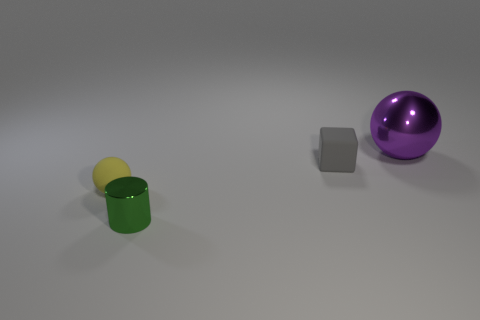There is a thing behind the gray matte cube; does it have the same shape as the tiny gray object?
Offer a very short reply. No. The shiny thing in front of the small gray rubber object has what shape?
Offer a terse response. Cylinder. What number of yellow matte balls are the same size as the yellow rubber thing?
Your response must be concise. 0. What is the color of the tiny sphere?
Make the answer very short. Yellow. There is a rubber ball; does it have the same color as the metal object on the left side of the big ball?
Ensure brevity in your answer.  No. The yellow sphere that is made of the same material as the gray object is what size?
Your answer should be compact. Small. Is there a sphere of the same color as the cylinder?
Ensure brevity in your answer.  No. How many objects are either spheres that are in front of the big purple metallic object or tiny gray matte spheres?
Your response must be concise. 1. Do the small green object and the sphere left of the purple sphere have the same material?
Your answer should be very brief. No. Is there a tiny green cylinder that has the same material as the tiny gray cube?
Give a very brief answer. No. 